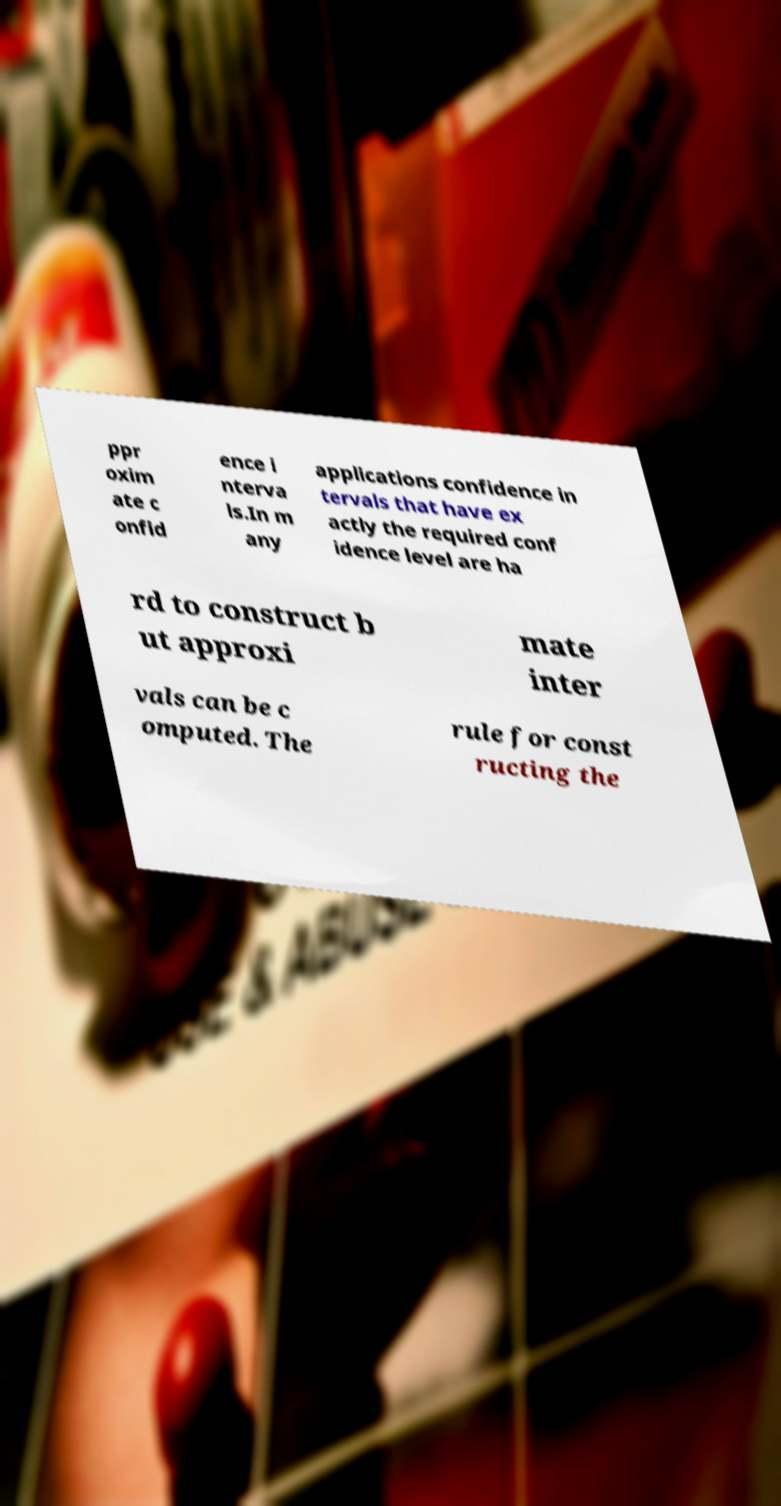Please read and relay the text visible in this image. What does it say? ppr oxim ate c onfid ence i nterva ls.In m any applications confidence in tervals that have ex actly the required conf idence level are ha rd to construct b ut approxi mate inter vals can be c omputed. The rule for const ructing the 